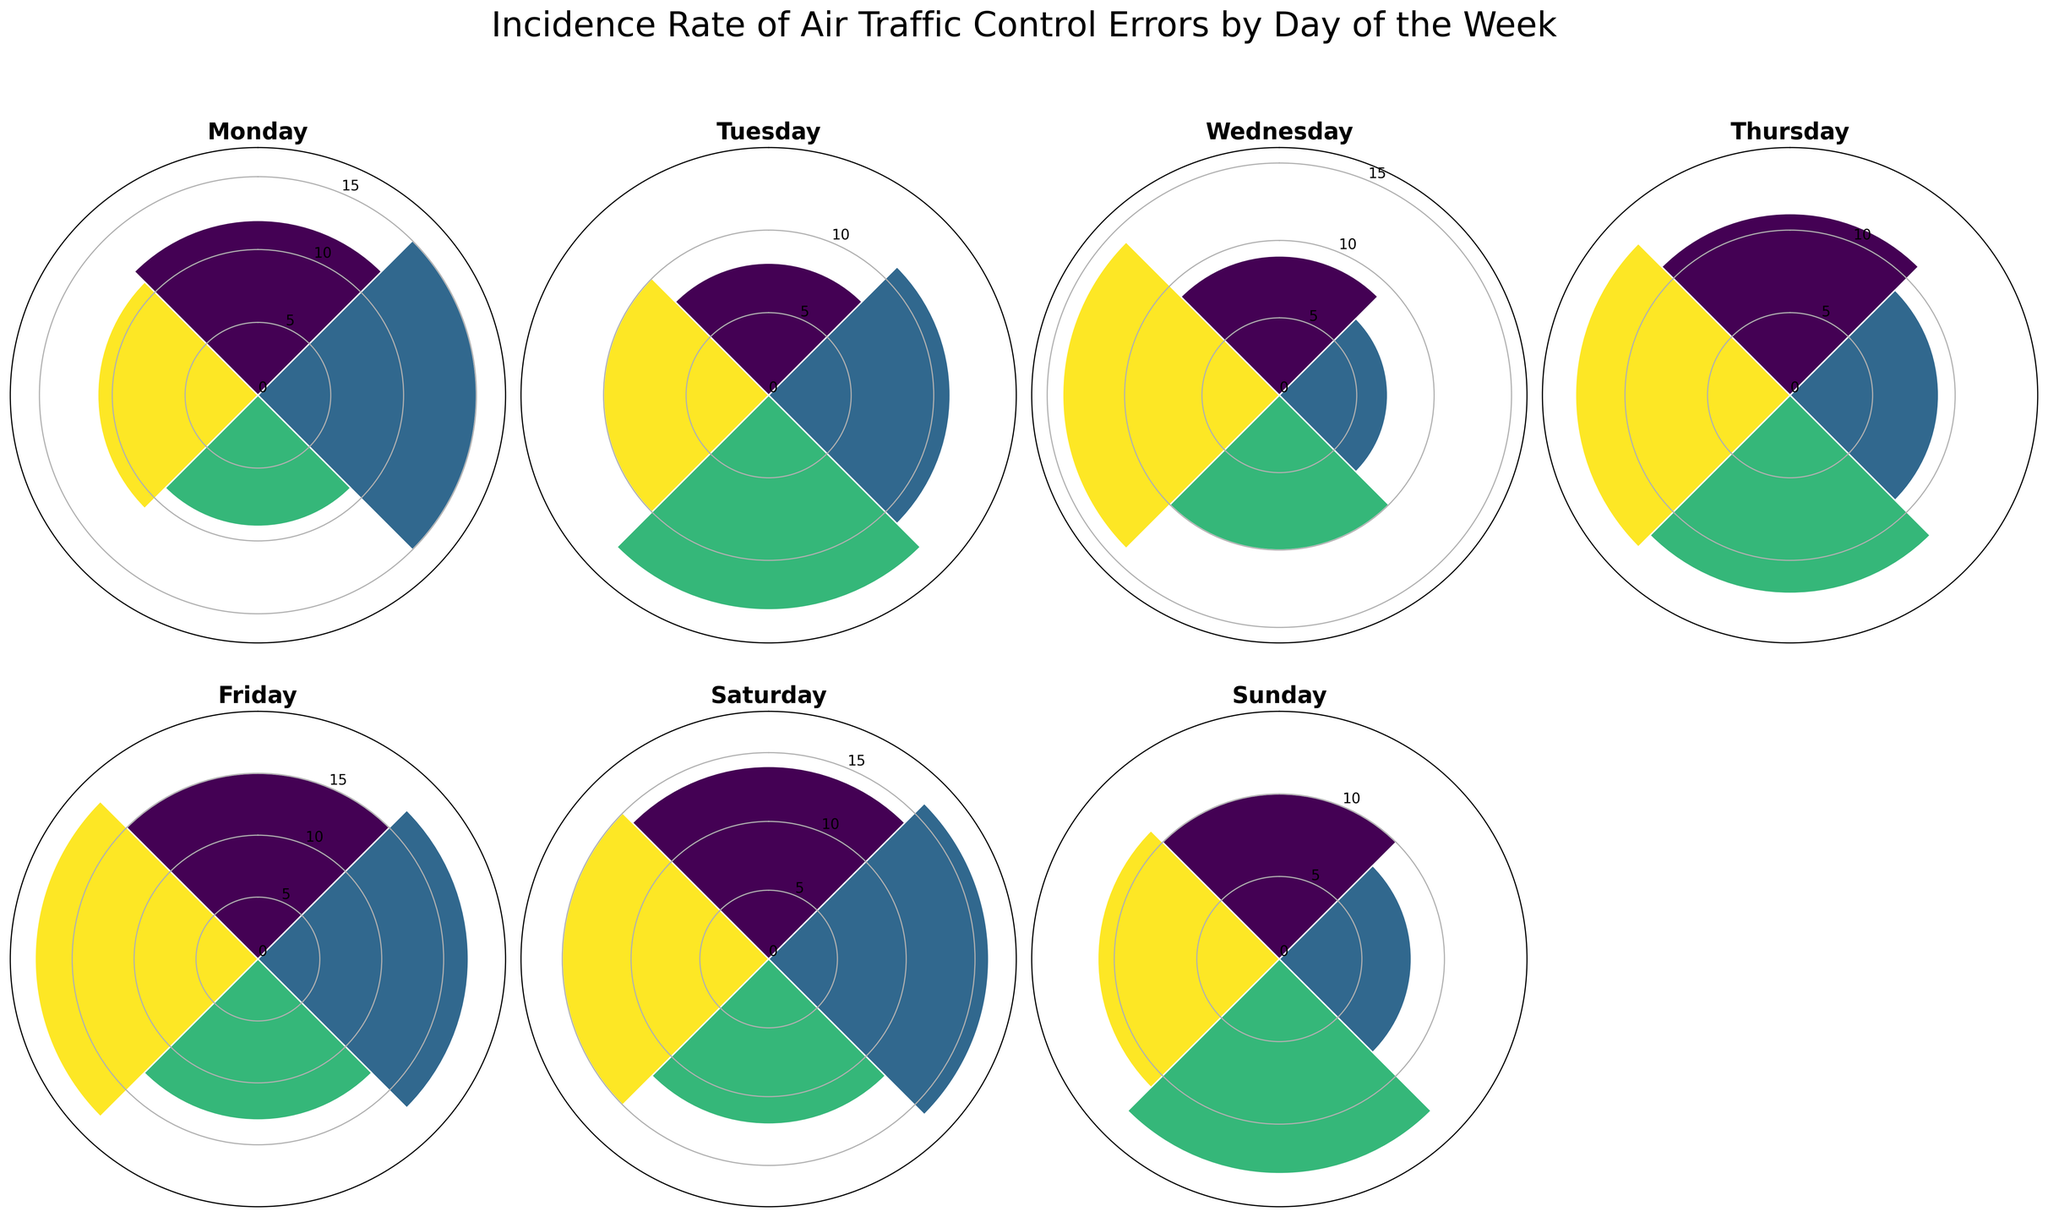What's the title of the figure? The title is displayed at the top of the overall figure area. It usually provides a description of what the data represents.
Answer: Incidence Rate of Air Traffic Control Errors by Day of the Week What color scheme is used for the bars in the plots? The bars in the plots use a gradient color scheme. This can be inferred from the varying colors seen in each rose plot for the different days.
Answer: Gradient Which day's error counts reach the highest radius? By comparing the highest bar in each subplot, we can see that Friday’s plot has the tallest bar.
Answer: Friday What is the maximum incidence rate of errors on Saturday? The tallest bar in the Saturday subplot represents the maximum incidence rate of errors for that day.
Answer: 16 On which day do the error bars have the most consistent heights? To identify this, observe which subplot has bars of roughly the same length. Wednesday and Sunday appear to have the most consistent heights.
Answer: Wednesday and Sunday Which day has the lowest maximum error count? Comparing the maximum length of bars across all subplots, Wednesday’s tallest bar is the shortest.
Answer: Wednesday What is the average incidence rate of errors on Tuesday? By summing up all Tuesday’s counts and dividing by the number of data points: (8 + 11 + 13 + 10) / 4 = 10.5.
Answer: 10.5 What is the difference between the maximum error counts on Monday and Thursday? First, identify the maximum counts for Monday (15) and Thursday (13). Then, subtract the smaller value from the larger one: 15 - 13 = 2.
Answer: 2 Which day shows a sudden increase in the maximum error counts from the previous day? Between the comparisons of adjacent days’ maximum values, note the significant rise: Friday’s maximum (18) sharply increases from Thursday’s maximum (13).
Answer: Friday 